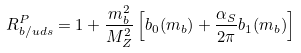<formula> <loc_0><loc_0><loc_500><loc_500>R _ { b / u d s } ^ { P } = 1 + \frac { m _ { b } ^ { 2 } } { M _ { Z } ^ { 2 } } \left [ b _ { 0 } ( m _ { b } ) + \frac { \alpha _ { S } } { 2 \pi } b _ { 1 } ( m _ { b } ) \right ]</formula> 